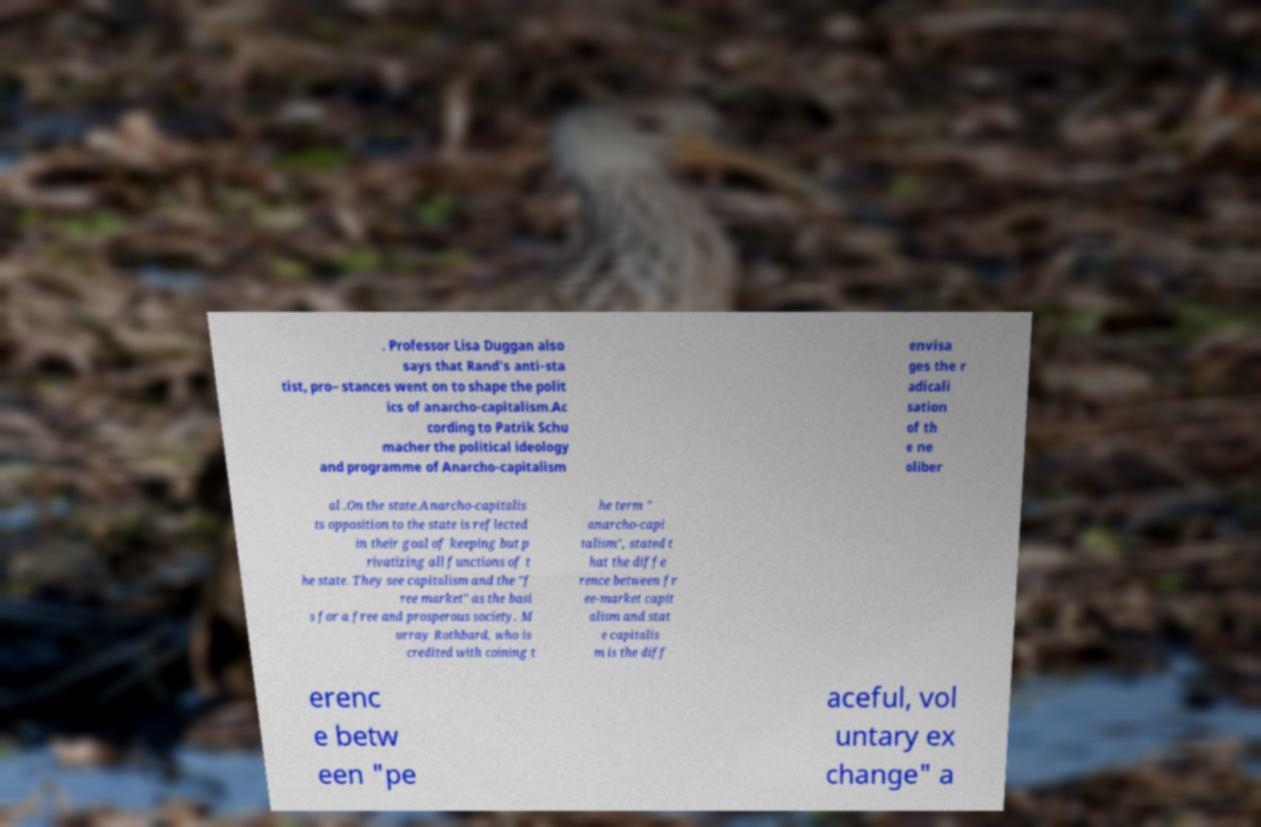What messages or text are displayed in this image? I need them in a readable, typed format. . Professor Lisa Duggan also says that Rand's anti-sta tist, pro– stances went on to shape the polit ics of anarcho-capitalism.Ac cording to Patrik Schu macher the political ideology and programme of Anarcho-capitalism envisa ges the r adicali sation of th e ne oliber al .On the state.Anarcho-capitalis ts opposition to the state is reflected in their goal of keeping but p rivatizing all functions of t he state. They see capitalism and the "f ree market" as the basi s for a free and prosperous society. M urray Rothbard, who is credited with coining t he term " anarcho-capi talism", stated t hat the diffe rence between fr ee-market capit alism and stat e capitalis m is the diff erenc e betw een "pe aceful, vol untary ex change" a 